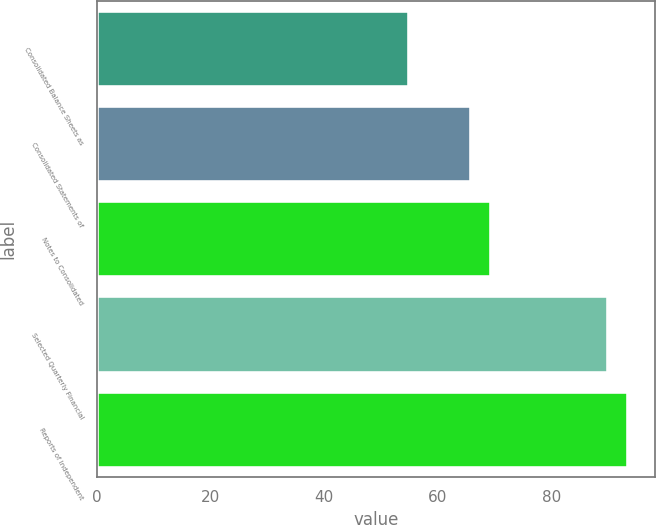Convert chart to OTSL. <chart><loc_0><loc_0><loc_500><loc_500><bar_chart><fcel>Consolidated Balance Sheets as<fcel>Consolidated Statements of<fcel>Notes to Consolidated<fcel>Selected Quarterly Financial<fcel>Reports of Independent<nl><fcel>55<fcel>65.8<fcel>69.4<fcel>90<fcel>93.6<nl></chart> 